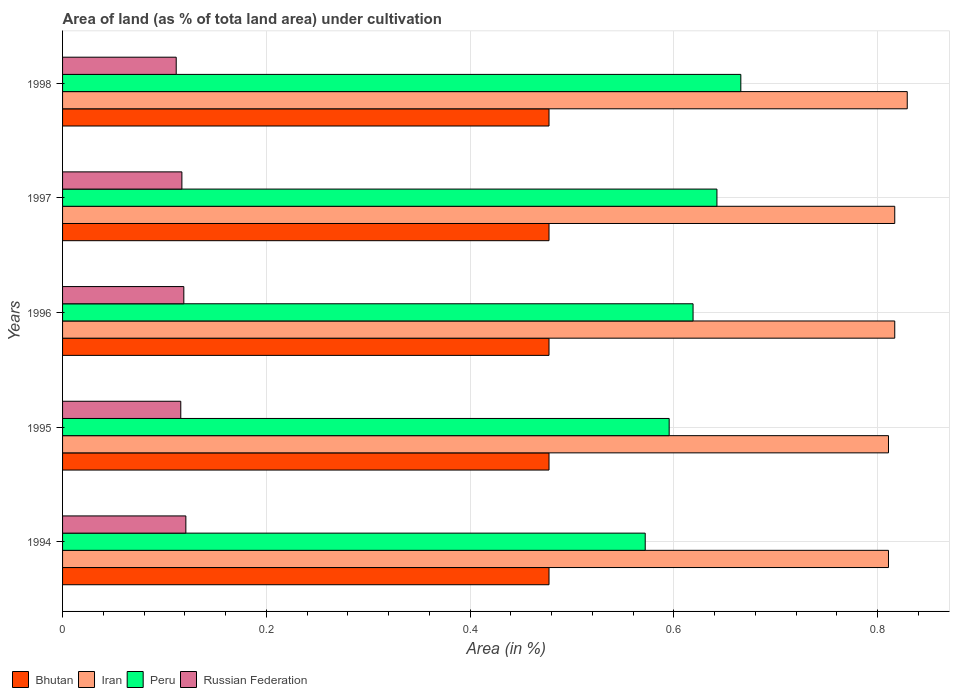How many different coloured bars are there?
Your response must be concise. 4. What is the label of the 2nd group of bars from the top?
Ensure brevity in your answer.  1997. In how many cases, is the number of bars for a given year not equal to the number of legend labels?
Offer a very short reply. 0. What is the percentage of land under cultivation in Peru in 1995?
Your answer should be compact. 0.6. Across all years, what is the maximum percentage of land under cultivation in Peru?
Provide a short and direct response. 0.67. Across all years, what is the minimum percentage of land under cultivation in Iran?
Make the answer very short. 0.81. In which year was the percentage of land under cultivation in Peru minimum?
Provide a succinct answer. 1994. What is the total percentage of land under cultivation in Bhutan in the graph?
Provide a succinct answer. 2.39. What is the difference between the percentage of land under cultivation in Iran in 1996 and that in 1998?
Your answer should be very brief. -0.01. What is the difference between the percentage of land under cultivation in Iran in 1998 and the percentage of land under cultivation in Russian Federation in 1997?
Offer a very short reply. 0.71. What is the average percentage of land under cultivation in Russian Federation per year?
Ensure brevity in your answer.  0.12. In the year 1997, what is the difference between the percentage of land under cultivation in Bhutan and percentage of land under cultivation in Peru?
Offer a very short reply. -0.16. In how many years, is the percentage of land under cultivation in Russian Federation greater than 0.68 %?
Provide a succinct answer. 0. Is the percentage of land under cultivation in Russian Federation in 1995 less than that in 1996?
Make the answer very short. Yes. Is the difference between the percentage of land under cultivation in Bhutan in 1994 and 1998 greater than the difference between the percentage of land under cultivation in Peru in 1994 and 1998?
Offer a terse response. Yes. What is the difference between the highest and the second highest percentage of land under cultivation in Bhutan?
Offer a terse response. 0. What is the difference between the highest and the lowest percentage of land under cultivation in Iran?
Your answer should be very brief. 0.02. What does the 3rd bar from the top in 1997 represents?
Offer a very short reply. Iran. What does the 1st bar from the bottom in 1994 represents?
Your answer should be very brief. Bhutan. Are all the bars in the graph horizontal?
Provide a short and direct response. Yes. Are the values on the major ticks of X-axis written in scientific E-notation?
Your answer should be very brief. No. How many legend labels are there?
Offer a very short reply. 4. What is the title of the graph?
Offer a very short reply. Area of land (as % of tota land area) under cultivation. What is the label or title of the X-axis?
Ensure brevity in your answer.  Area (in %). What is the label or title of the Y-axis?
Ensure brevity in your answer.  Years. What is the Area (in %) of Bhutan in 1994?
Ensure brevity in your answer.  0.48. What is the Area (in %) in Iran in 1994?
Offer a very short reply. 0.81. What is the Area (in %) in Peru in 1994?
Your answer should be very brief. 0.57. What is the Area (in %) of Russian Federation in 1994?
Provide a succinct answer. 0.12. What is the Area (in %) in Bhutan in 1995?
Keep it short and to the point. 0.48. What is the Area (in %) in Iran in 1995?
Your response must be concise. 0.81. What is the Area (in %) of Peru in 1995?
Your answer should be compact. 0.6. What is the Area (in %) of Russian Federation in 1995?
Make the answer very short. 0.12. What is the Area (in %) of Bhutan in 1996?
Provide a succinct answer. 0.48. What is the Area (in %) in Iran in 1996?
Provide a short and direct response. 0.82. What is the Area (in %) of Peru in 1996?
Offer a very short reply. 0.62. What is the Area (in %) in Russian Federation in 1996?
Offer a terse response. 0.12. What is the Area (in %) in Bhutan in 1997?
Your answer should be very brief. 0.48. What is the Area (in %) of Iran in 1997?
Offer a terse response. 0.82. What is the Area (in %) in Peru in 1997?
Give a very brief answer. 0.64. What is the Area (in %) in Russian Federation in 1997?
Provide a short and direct response. 0.12. What is the Area (in %) of Bhutan in 1998?
Make the answer very short. 0.48. What is the Area (in %) of Iran in 1998?
Your answer should be very brief. 0.83. What is the Area (in %) of Peru in 1998?
Your answer should be very brief. 0.67. What is the Area (in %) in Russian Federation in 1998?
Give a very brief answer. 0.11. Across all years, what is the maximum Area (in %) of Bhutan?
Provide a short and direct response. 0.48. Across all years, what is the maximum Area (in %) in Iran?
Keep it short and to the point. 0.83. Across all years, what is the maximum Area (in %) of Peru?
Offer a terse response. 0.67. Across all years, what is the maximum Area (in %) in Russian Federation?
Provide a succinct answer. 0.12. Across all years, what is the minimum Area (in %) of Bhutan?
Your answer should be compact. 0.48. Across all years, what is the minimum Area (in %) of Iran?
Ensure brevity in your answer.  0.81. Across all years, what is the minimum Area (in %) in Peru?
Keep it short and to the point. 0.57. Across all years, what is the minimum Area (in %) of Russian Federation?
Make the answer very short. 0.11. What is the total Area (in %) of Bhutan in the graph?
Make the answer very short. 2.39. What is the total Area (in %) of Iran in the graph?
Your answer should be very brief. 4.08. What is the total Area (in %) in Peru in the graph?
Your answer should be compact. 3.09. What is the total Area (in %) of Russian Federation in the graph?
Ensure brevity in your answer.  0.58. What is the difference between the Area (in %) of Bhutan in 1994 and that in 1995?
Your response must be concise. 0. What is the difference between the Area (in %) in Peru in 1994 and that in 1995?
Keep it short and to the point. -0.02. What is the difference between the Area (in %) of Russian Federation in 1994 and that in 1995?
Your answer should be very brief. 0.01. What is the difference between the Area (in %) of Bhutan in 1994 and that in 1996?
Ensure brevity in your answer.  0. What is the difference between the Area (in %) in Iran in 1994 and that in 1996?
Make the answer very short. -0.01. What is the difference between the Area (in %) in Peru in 1994 and that in 1996?
Keep it short and to the point. -0.05. What is the difference between the Area (in %) in Russian Federation in 1994 and that in 1996?
Your response must be concise. 0. What is the difference between the Area (in %) in Iran in 1994 and that in 1997?
Provide a succinct answer. -0.01. What is the difference between the Area (in %) in Peru in 1994 and that in 1997?
Give a very brief answer. -0.07. What is the difference between the Area (in %) in Russian Federation in 1994 and that in 1997?
Offer a terse response. 0. What is the difference between the Area (in %) in Iran in 1994 and that in 1998?
Provide a short and direct response. -0.02. What is the difference between the Area (in %) in Peru in 1994 and that in 1998?
Provide a short and direct response. -0.09. What is the difference between the Area (in %) in Russian Federation in 1994 and that in 1998?
Keep it short and to the point. 0.01. What is the difference between the Area (in %) in Iran in 1995 and that in 1996?
Your answer should be very brief. -0.01. What is the difference between the Area (in %) in Peru in 1995 and that in 1996?
Make the answer very short. -0.02. What is the difference between the Area (in %) of Russian Federation in 1995 and that in 1996?
Provide a short and direct response. -0. What is the difference between the Area (in %) in Bhutan in 1995 and that in 1997?
Give a very brief answer. 0. What is the difference between the Area (in %) in Iran in 1995 and that in 1997?
Provide a succinct answer. -0.01. What is the difference between the Area (in %) in Peru in 1995 and that in 1997?
Keep it short and to the point. -0.05. What is the difference between the Area (in %) in Russian Federation in 1995 and that in 1997?
Your answer should be compact. -0. What is the difference between the Area (in %) of Iran in 1995 and that in 1998?
Your answer should be very brief. -0.02. What is the difference between the Area (in %) in Peru in 1995 and that in 1998?
Your response must be concise. -0.07. What is the difference between the Area (in %) of Russian Federation in 1995 and that in 1998?
Your response must be concise. 0. What is the difference between the Area (in %) of Iran in 1996 and that in 1997?
Offer a terse response. 0. What is the difference between the Area (in %) of Peru in 1996 and that in 1997?
Your response must be concise. -0.02. What is the difference between the Area (in %) in Russian Federation in 1996 and that in 1997?
Give a very brief answer. 0. What is the difference between the Area (in %) in Iran in 1996 and that in 1998?
Your response must be concise. -0.01. What is the difference between the Area (in %) of Peru in 1996 and that in 1998?
Offer a very short reply. -0.05. What is the difference between the Area (in %) of Russian Federation in 1996 and that in 1998?
Provide a short and direct response. 0.01. What is the difference between the Area (in %) in Bhutan in 1997 and that in 1998?
Offer a very short reply. 0. What is the difference between the Area (in %) of Iran in 1997 and that in 1998?
Provide a short and direct response. -0.01. What is the difference between the Area (in %) in Peru in 1997 and that in 1998?
Your answer should be compact. -0.02. What is the difference between the Area (in %) of Russian Federation in 1997 and that in 1998?
Ensure brevity in your answer.  0.01. What is the difference between the Area (in %) in Bhutan in 1994 and the Area (in %) in Iran in 1995?
Make the answer very short. -0.33. What is the difference between the Area (in %) in Bhutan in 1994 and the Area (in %) in Peru in 1995?
Your response must be concise. -0.12. What is the difference between the Area (in %) in Bhutan in 1994 and the Area (in %) in Russian Federation in 1995?
Offer a very short reply. 0.36. What is the difference between the Area (in %) in Iran in 1994 and the Area (in %) in Peru in 1995?
Provide a succinct answer. 0.22. What is the difference between the Area (in %) of Iran in 1994 and the Area (in %) of Russian Federation in 1995?
Keep it short and to the point. 0.69. What is the difference between the Area (in %) of Peru in 1994 and the Area (in %) of Russian Federation in 1995?
Keep it short and to the point. 0.46. What is the difference between the Area (in %) of Bhutan in 1994 and the Area (in %) of Iran in 1996?
Keep it short and to the point. -0.34. What is the difference between the Area (in %) in Bhutan in 1994 and the Area (in %) in Peru in 1996?
Offer a terse response. -0.14. What is the difference between the Area (in %) of Bhutan in 1994 and the Area (in %) of Russian Federation in 1996?
Provide a succinct answer. 0.36. What is the difference between the Area (in %) in Iran in 1994 and the Area (in %) in Peru in 1996?
Provide a succinct answer. 0.19. What is the difference between the Area (in %) in Iran in 1994 and the Area (in %) in Russian Federation in 1996?
Make the answer very short. 0.69. What is the difference between the Area (in %) of Peru in 1994 and the Area (in %) of Russian Federation in 1996?
Provide a short and direct response. 0.45. What is the difference between the Area (in %) in Bhutan in 1994 and the Area (in %) in Iran in 1997?
Offer a very short reply. -0.34. What is the difference between the Area (in %) of Bhutan in 1994 and the Area (in %) of Peru in 1997?
Your answer should be compact. -0.16. What is the difference between the Area (in %) of Bhutan in 1994 and the Area (in %) of Russian Federation in 1997?
Offer a terse response. 0.36. What is the difference between the Area (in %) of Iran in 1994 and the Area (in %) of Peru in 1997?
Keep it short and to the point. 0.17. What is the difference between the Area (in %) in Iran in 1994 and the Area (in %) in Russian Federation in 1997?
Offer a terse response. 0.69. What is the difference between the Area (in %) of Peru in 1994 and the Area (in %) of Russian Federation in 1997?
Ensure brevity in your answer.  0.45. What is the difference between the Area (in %) of Bhutan in 1994 and the Area (in %) of Iran in 1998?
Make the answer very short. -0.35. What is the difference between the Area (in %) of Bhutan in 1994 and the Area (in %) of Peru in 1998?
Your response must be concise. -0.19. What is the difference between the Area (in %) in Bhutan in 1994 and the Area (in %) in Russian Federation in 1998?
Offer a terse response. 0.37. What is the difference between the Area (in %) of Iran in 1994 and the Area (in %) of Peru in 1998?
Keep it short and to the point. 0.14. What is the difference between the Area (in %) of Iran in 1994 and the Area (in %) of Russian Federation in 1998?
Provide a succinct answer. 0.7. What is the difference between the Area (in %) in Peru in 1994 and the Area (in %) in Russian Federation in 1998?
Provide a succinct answer. 0.46. What is the difference between the Area (in %) of Bhutan in 1995 and the Area (in %) of Iran in 1996?
Keep it short and to the point. -0.34. What is the difference between the Area (in %) of Bhutan in 1995 and the Area (in %) of Peru in 1996?
Your response must be concise. -0.14. What is the difference between the Area (in %) of Bhutan in 1995 and the Area (in %) of Russian Federation in 1996?
Ensure brevity in your answer.  0.36. What is the difference between the Area (in %) in Iran in 1995 and the Area (in %) in Peru in 1996?
Keep it short and to the point. 0.19. What is the difference between the Area (in %) of Iran in 1995 and the Area (in %) of Russian Federation in 1996?
Offer a very short reply. 0.69. What is the difference between the Area (in %) of Peru in 1995 and the Area (in %) of Russian Federation in 1996?
Your response must be concise. 0.48. What is the difference between the Area (in %) of Bhutan in 1995 and the Area (in %) of Iran in 1997?
Give a very brief answer. -0.34. What is the difference between the Area (in %) of Bhutan in 1995 and the Area (in %) of Peru in 1997?
Give a very brief answer. -0.16. What is the difference between the Area (in %) of Bhutan in 1995 and the Area (in %) of Russian Federation in 1997?
Keep it short and to the point. 0.36. What is the difference between the Area (in %) of Iran in 1995 and the Area (in %) of Peru in 1997?
Offer a very short reply. 0.17. What is the difference between the Area (in %) of Iran in 1995 and the Area (in %) of Russian Federation in 1997?
Ensure brevity in your answer.  0.69. What is the difference between the Area (in %) of Peru in 1995 and the Area (in %) of Russian Federation in 1997?
Give a very brief answer. 0.48. What is the difference between the Area (in %) of Bhutan in 1995 and the Area (in %) of Iran in 1998?
Your response must be concise. -0.35. What is the difference between the Area (in %) of Bhutan in 1995 and the Area (in %) of Peru in 1998?
Keep it short and to the point. -0.19. What is the difference between the Area (in %) of Bhutan in 1995 and the Area (in %) of Russian Federation in 1998?
Your answer should be compact. 0.37. What is the difference between the Area (in %) of Iran in 1995 and the Area (in %) of Peru in 1998?
Offer a terse response. 0.14. What is the difference between the Area (in %) in Iran in 1995 and the Area (in %) in Russian Federation in 1998?
Keep it short and to the point. 0.7. What is the difference between the Area (in %) in Peru in 1995 and the Area (in %) in Russian Federation in 1998?
Offer a terse response. 0.48. What is the difference between the Area (in %) in Bhutan in 1996 and the Area (in %) in Iran in 1997?
Keep it short and to the point. -0.34. What is the difference between the Area (in %) in Bhutan in 1996 and the Area (in %) in Peru in 1997?
Offer a very short reply. -0.16. What is the difference between the Area (in %) in Bhutan in 1996 and the Area (in %) in Russian Federation in 1997?
Keep it short and to the point. 0.36. What is the difference between the Area (in %) in Iran in 1996 and the Area (in %) in Peru in 1997?
Your answer should be very brief. 0.17. What is the difference between the Area (in %) in Iran in 1996 and the Area (in %) in Russian Federation in 1997?
Offer a very short reply. 0.7. What is the difference between the Area (in %) in Peru in 1996 and the Area (in %) in Russian Federation in 1997?
Your answer should be compact. 0.5. What is the difference between the Area (in %) of Bhutan in 1996 and the Area (in %) of Iran in 1998?
Give a very brief answer. -0.35. What is the difference between the Area (in %) of Bhutan in 1996 and the Area (in %) of Peru in 1998?
Offer a very short reply. -0.19. What is the difference between the Area (in %) of Bhutan in 1996 and the Area (in %) of Russian Federation in 1998?
Offer a terse response. 0.37. What is the difference between the Area (in %) of Iran in 1996 and the Area (in %) of Peru in 1998?
Offer a terse response. 0.15. What is the difference between the Area (in %) of Iran in 1996 and the Area (in %) of Russian Federation in 1998?
Keep it short and to the point. 0.71. What is the difference between the Area (in %) in Peru in 1996 and the Area (in %) in Russian Federation in 1998?
Offer a terse response. 0.51. What is the difference between the Area (in %) of Bhutan in 1997 and the Area (in %) of Iran in 1998?
Make the answer very short. -0.35. What is the difference between the Area (in %) in Bhutan in 1997 and the Area (in %) in Peru in 1998?
Keep it short and to the point. -0.19. What is the difference between the Area (in %) in Bhutan in 1997 and the Area (in %) in Russian Federation in 1998?
Ensure brevity in your answer.  0.37. What is the difference between the Area (in %) in Iran in 1997 and the Area (in %) in Peru in 1998?
Your answer should be very brief. 0.15. What is the difference between the Area (in %) in Iran in 1997 and the Area (in %) in Russian Federation in 1998?
Make the answer very short. 0.71. What is the difference between the Area (in %) in Peru in 1997 and the Area (in %) in Russian Federation in 1998?
Provide a succinct answer. 0.53. What is the average Area (in %) in Bhutan per year?
Ensure brevity in your answer.  0.48. What is the average Area (in %) in Iran per year?
Make the answer very short. 0.82. What is the average Area (in %) in Peru per year?
Offer a very short reply. 0.62. What is the average Area (in %) in Russian Federation per year?
Make the answer very short. 0.12. In the year 1994, what is the difference between the Area (in %) in Bhutan and Area (in %) in Iran?
Offer a terse response. -0.33. In the year 1994, what is the difference between the Area (in %) of Bhutan and Area (in %) of Peru?
Your response must be concise. -0.09. In the year 1994, what is the difference between the Area (in %) of Bhutan and Area (in %) of Russian Federation?
Your answer should be compact. 0.36. In the year 1994, what is the difference between the Area (in %) of Iran and Area (in %) of Peru?
Your answer should be compact. 0.24. In the year 1994, what is the difference between the Area (in %) of Iran and Area (in %) of Russian Federation?
Make the answer very short. 0.69. In the year 1994, what is the difference between the Area (in %) of Peru and Area (in %) of Russian Federation?
Your answer should be compact. 0.45. In the year 1995, what is the difference between the Area (in %) of Bhutan and Area (in %) of Iran?
Offer a terse response. -0.33. In the year 1995, what is the difference between the Area (in %) in Bhutan and Area (in %) in Peru?
Ensure brevity in your answer.  -0.12. In the year 1995, what is the difference between the Area (in %) in Bhutan and Area (in %) in Russian Federation?
Give a very brief answer. 0.36. In the year 1995, what is the difference between the Area (in %) of Iran and Area (in %) of Peru?
Ensure brevity in your answer.  0.22. In the year 1995, what is the difference between the Area (in %) in Iran and Area (in %) in Russian Federation?
Your answer should be compact. 0.69. In the year 1995, what is the difference between the Area (in %) in Peru and Area (in %) in Russian Federation?
Offer a very short reply. 0.48. In the year 1996, what is the difference between the Area (in %) of Bhutan and Area (in %) of Iran?
Give a very brief answer. -0.34. In the year 1996, what is the difference between the Area (in %) in Bhutan and Area (in %) in Peru?
Your answer should be very brief. -0.14. In the year 1996, what is the difference between the Area (in %) of Bhutan and Area (in %) of Russian Federation?
Make the answer very short. 0.36. In the year 1996, what is the difference between the Area (in %) in Iran and Area (in %) in Peru?
Provide a short and direct response. 0.2. In the year 1996, what is the difference between the Area (in %) of Iran and Area (in %) of Russian Federation?
Offer a terse response. 0.7. In the year 1996, what is the difference between the Area (in %) of Peru and Area (in %) of Russian Federation?
Provide a short and direct response. 0.5. In the year 1997, what is the difference between the Area (in %) of Bhutan and Area (in %) of Iran?
Make the answer very short. -0.34. In the year 1997, what is the difference between the Area (in %) of Bhutan and Area (in %) of Peru?
Your answer should be very brief. -0.16. In the year 1997, what is the difference between the Area (in %) of Bhutan and Area (in %) of Russian Federation?
Ensure brevity in your answer.  0.36. In the year 1997, what is the difference between the Area (in %) of Iran and Area (in %) of Peru?
Keep it short and to the point. 0.17. In the year 1997, what is the difference between the Area (in %) of Iran and Area (in %) of Russian Federation?
Offer a very short reply. 0.7. In the year 1997, what is the difference between the Area (in %) of Peru and Area (in %) of Russian Federation?
Provide a short and direct response. 0.53. In the year 1998, what is the difference between the Area (in %) in Bhutan and Area (in %) in Iran?
Offer a terse response. -0.35. In the year 1998, what is the difference between the Area (in %) in Bhutan and Area (in %) in Peru?
Make the answer very short. -0.19. In the year 1998, what is the difference between the Area (in %) of Bhutan and Area (in %) of Russian Federation?
Give a very brief answer. 0.37. In the year 1998, what is the difference between the Area (in %) of Iran and Area (in %) of Peru?
Offer a terse response. 0.16. In the year 1998, what is the difference between the Area (in %) of Iran and Area (in %) of Russian Federation?
Offer a very short reply. 0.72. In the year 1998, what is the difference between the Area (in %) of Peru and Area (in %) of Russian Federation?
Offer a terse response. 0.55. What is the ratio of the Area (in %) in Bhutan in 1994 to that in 1995?
Keep it short and to the point. 1. What is the ratio of the Area (in %) in Iran in 1994 to that in 1995?
Your answer should be compact. 1. What is the ratio of the Area (in %) of Peru in 1994 to that in 1995?
Your response must be concise. 0.96. What is the ratio of the Area (in %) in Russian Federation in 1994 to that in 1995?
Provide a short and direct response. 1.04. What is the ratio of the Area (in %) of Peru in 1994 to that in 1996?
Provide a succinct answer. 0.92. What is the ratio of the Area (in %) in Russian Federation in 1994 to that in 1996?
Offer a terse response. 1.02. What is the ratio of the Area (in %) in Bhutan in 1994 to that in 1997?
Make the answer very short. 1. What is the ratio of the Area (in %) of Iran in 1994 to that in 1997?
Your response must be concise. 0.99. What is the ratio of the Area (in %) of Peru in 1994 to that in 1997?
Your answer should be compact. 0.89. What is the ratio of the Area (in %) of Russian Federation in 1994 to that in 1997?
Ensure brevity in your answer.  1.03. What is the ratio of the Area (in %) of Bhutan in 1994 to that in 1998?
Offer a terse response. 1. What is the ratio of the Area (in %) in Iran in 1994 to that in 1998?
Offer a terse response. 0.98. What is the ratio of the Area (in %) of Peru in 1994 to that in 1998?
Offer a very short reply. 0.86. What is the ratio of the Area (in %) in Russian Federation in 1994 to that in 1998?
Your response must be concise. 1.08. What is the ratio of the Area (in %) of Peru in 1995 to that in 1996?
Your response must be concise. 0.96. What is the ratio of the Area (in %) in Russian Federation in 1995 to that in 1996?
Keep it short and to the point. 0.97. What is the ratio of the Area (in %) of Iran in 1995 to that in 1997?
Your answer should be very brief. 0.99. What is the ratio of the Area (in %) in Peru in 1995 to that in 1997?
Provide a succinct answer. 0.93. What is the ratio of the Area (in %) of Russian Federation in 1995 to that in 1997?
Your answer should be very brief. 0.99. What is the ratio of the Area (in %) in Bhutan in 1995 to that in 1998?
Your response must be concise. 1. What is the ratio of the Area (in %) in Iran in 1995 to that in 1998?
Give a very brief answer. 0.98. What is the ratio of the Area (in %) of Peru in 1995 to that in 1998?
Your answer should be compact. 0.89. What is the ratio of the Area (in %) in Russian Federation in 1995 to that in 1998?
Keep it short and to the point. 1.04. What is the ratio of the Area (in %) in Bhutan in 1996 to that in 1997?
Your response must be concise. 1. What is the ratio of the Area (in %) in Peru in 1996 to that in 1997?
Give a very brief answer. 0.96. What is the ratio of the Area (in %) in Russian Federation in 1996 to that in 1997?
Offer a very short reply. 1.02. What is the ratio of the Area (in %) in Bhutan in 1996 to that in 1998?
Your answer should be very brief. 1. What is the ratio of the Area (in %) of Iran in 1996 to that in 1998?
Keep it short and to the point. 0.99. What is the ratio of the Area (in %) of Peru in 1996 to that in 1998?
Your answer should be compact. 0.93. What is the ratio of the Area (in %) of Russian Federation in 1996 to that in 1998?
Provide a succinct answer. 1.07. What is the ratio of the Area (in %) in Iran in 1997 to that in 1998?
Provide a short and direct response. 0.99. What is the ratio of the Area (in %) in Peru in 1997 to that in 1998?
Your answer should be very brief. 0.96. What is the ratio of the Area (in %) of Russian Federation in 1997 to that in 1998?
Ensure brevity in your answer.  1.05. What is the difference between the highest and the second highest Area (in %) of Iran?
Provide a succinct answer. 0.01. What is the difference between the highest and the second highest Area (in %) of Peru?
Make the answer very short. 0.02. What is the difference between the highest and the second highest Area (in %) in Russian Federation?
Keep it short and to the point. 0. What is the difference between the highest and the lowest Area (in %) of Bhutan?
Provide a succinct answer. 0. What is the difference between the highest and the lowest Area (in %) in Iran?
Give a very brief answer. 0.02. What is the difference between the highest and the lowest Area (in %) of Peru?
Your answer should be very brief. 0.09. What is the difference between the highest and the lowest Area (in %) in Russian Federation?
Provide a short and direct response. 0.01. 